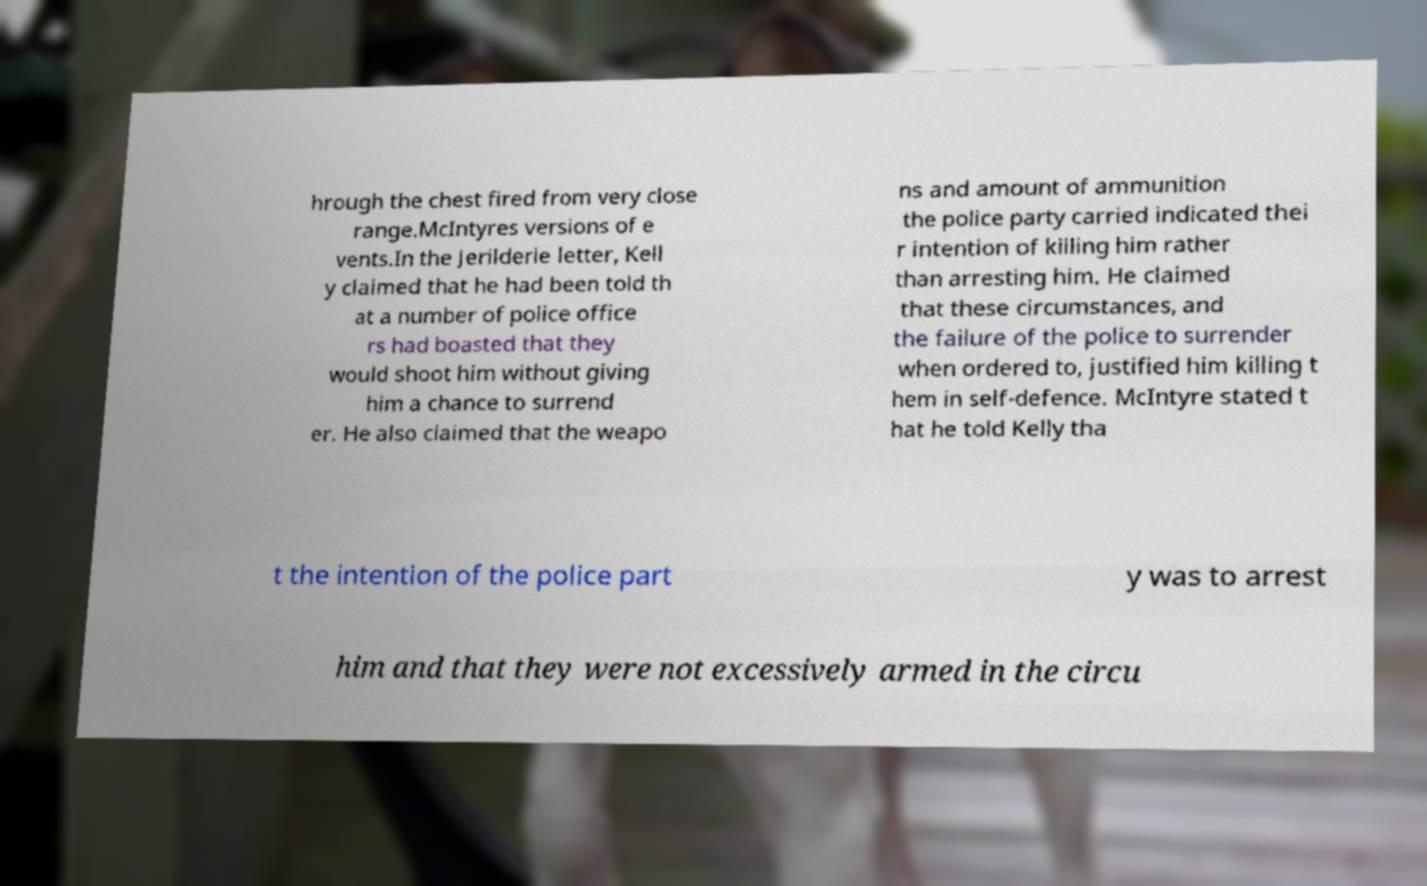For documentation purposes, I need the text within this image transcribed. Could you provide that? hrough the chest fired from very close range.McIntyres versions of e vents.In the Jerilderie letter, Kell y claimed that he had been told th at a number of police office rs had boasted that they would shoot him without giving him a chance to surrend er. He also claimed that the weapo ns and amount of ammunition the police party carried indicated thei r intention of killing him rather than arresting him. He claimed that these circumstances, and the failure of the police to surrender when ordered to, justified him killing t hem in self-defence. McIntyre stated t hat he told Kelly tha t the intention of the police part y was to arrest him and that they were not excessively armed in the circu 